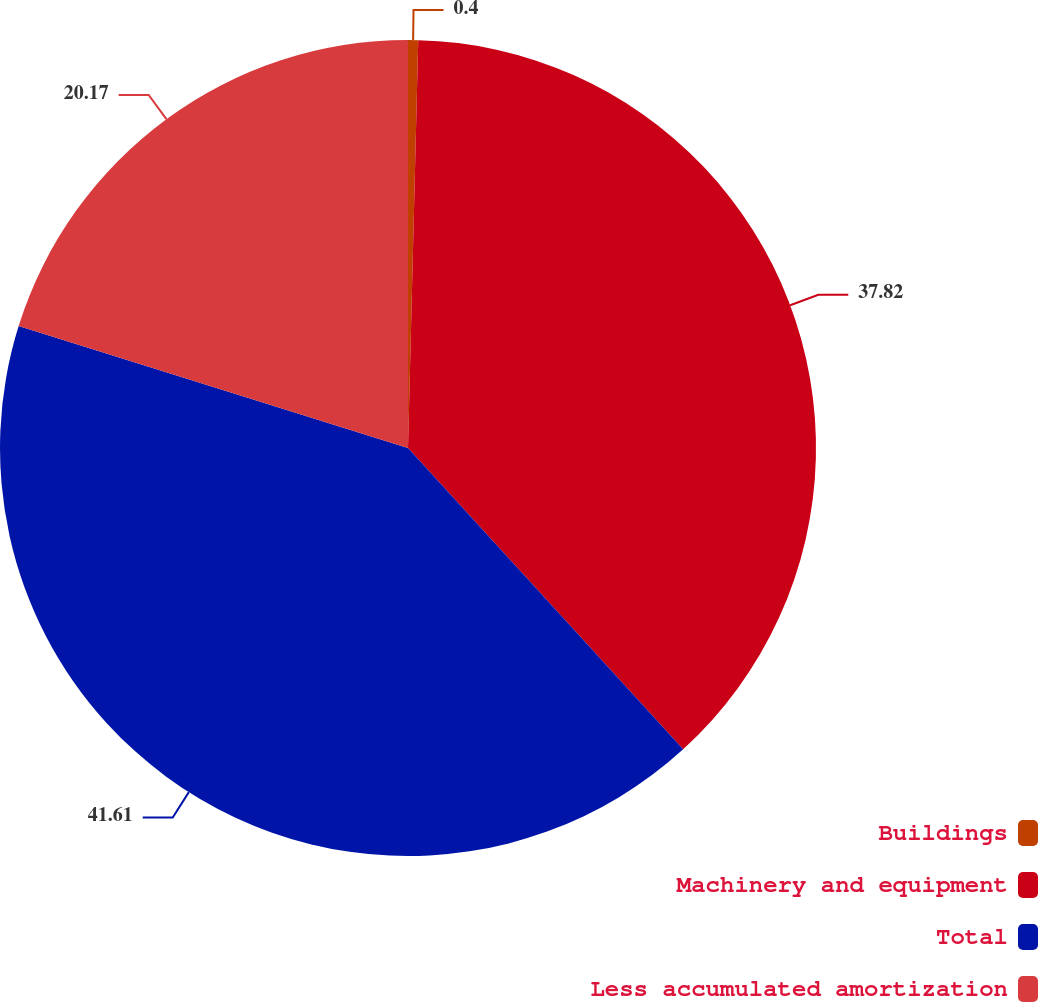Convert chart. <chart><loc_0><loc_0><loc_500><loc_500><pie_chart><fcel>Buildings<fcel>Machinery and equipment<fcel>Total<fcel>Less accumulated amortization<nl><fcel>0.4%<fcel>37.82%<fcel>41.61%<fcel>20.17%<nl></chart> 